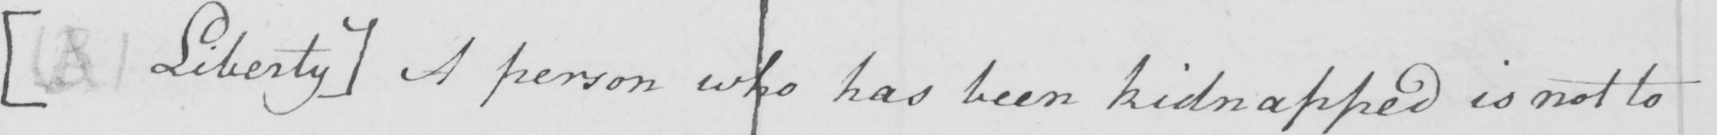Please provide the text content of this handwritten line. [  ( B )  Liberty ]  A person who has been kidnapped is not to 